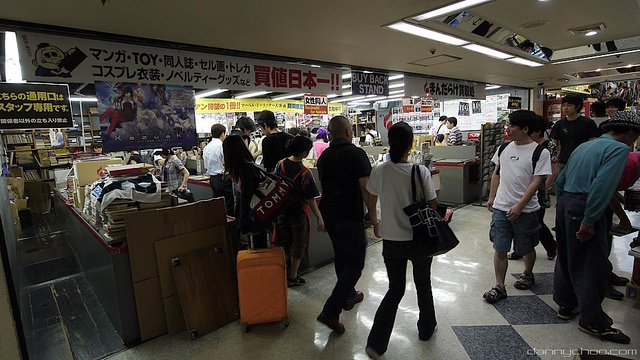Describe the objects in this image and their specific colors. I can see people in black, blue, gray, and darkblue tones, people in black, gray, and darkgray tones, people in black, darkgray, and gray tones, people in black and gray tones, and people in black, gray, lightgray, and darkgray tones in this image. 